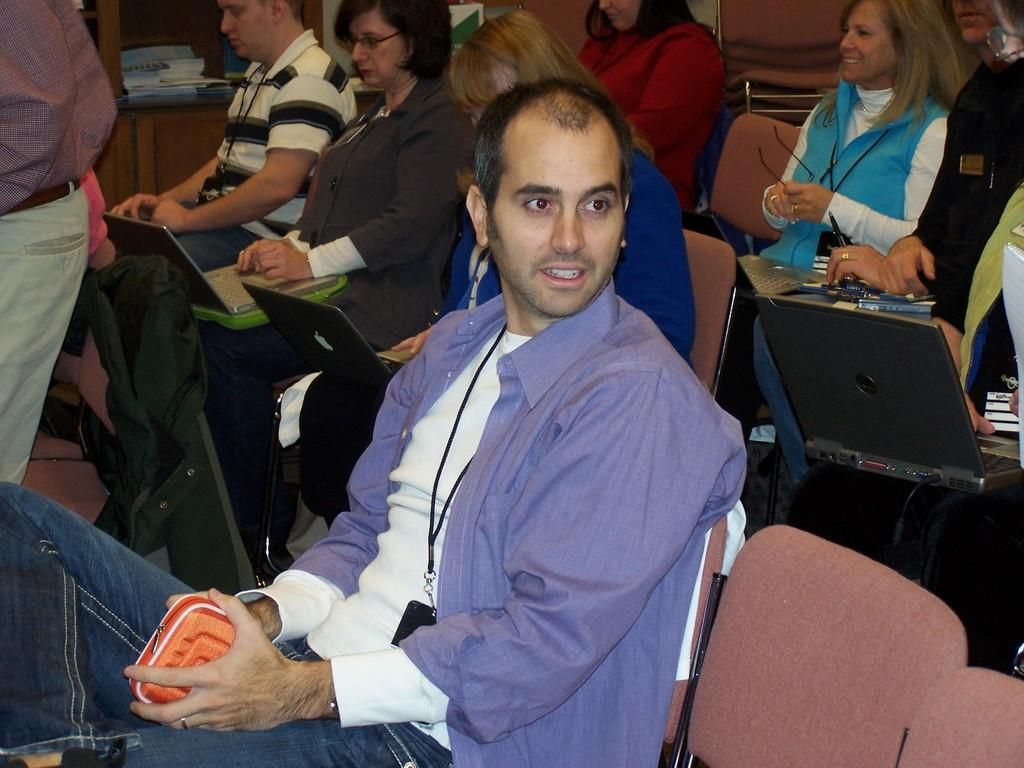What are the people in the image doing? The people in the image are sitting on chairs. What are some people holding in the image? Some people are holding laptops in the image. What else are people holding in the image? There are other objects being held by people in the image. What can be seen in the background of the image? There is a cupboard visible in the background of the image. What is inside the cupboard? There are objects inside the cupboard. What type of game is being played on the egg in the image? There is no egg or game present in the image. What type of shop is visible in the background of the image? There is no shop visible in the background of the image. 